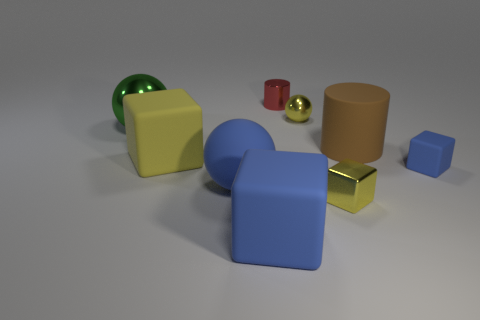What can you infer about the scale of the objects in relation to each other? The objects exhibit a variety of scales, with the blue cube appearing significantly larger than the tiny blue cube and the golden yellow cuboid. The large matte cylinder and the glossy green sphere also seem quite substantial when compared to the small red cylinder and the tiny golden sphere. These differences in scale help to create a sense of depth and perspective within the image. 